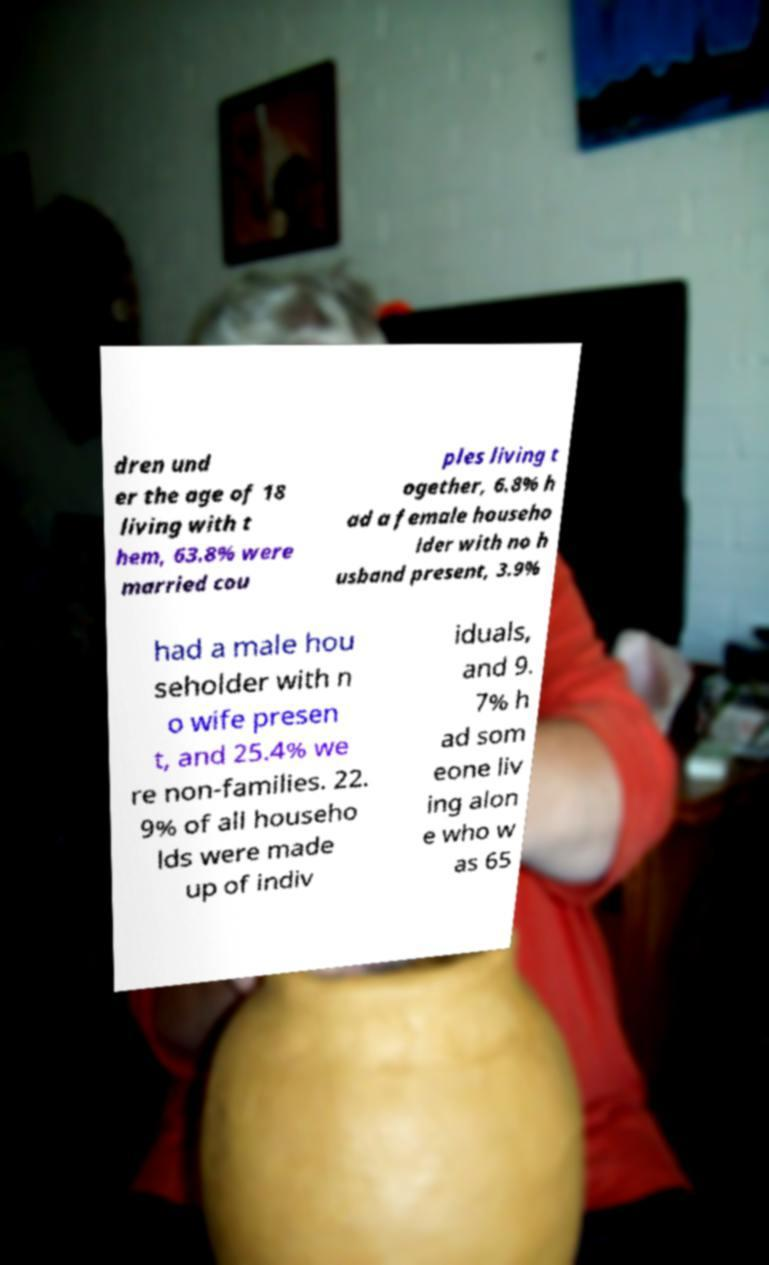There's text embedded in this image that I need extracted. Can you transcribe it verbatim? The image shows a piece of paper with printed statistics about household composition. Due to obstruction, not all text on the paper can be fully seen or transcribed. What's captured mentions percentages of married couples, individuals living alone, and non-family households. To ensure accuracy and transparency, it's acknowledged that the full content cannot be provided due to the partial visibility in the image. 